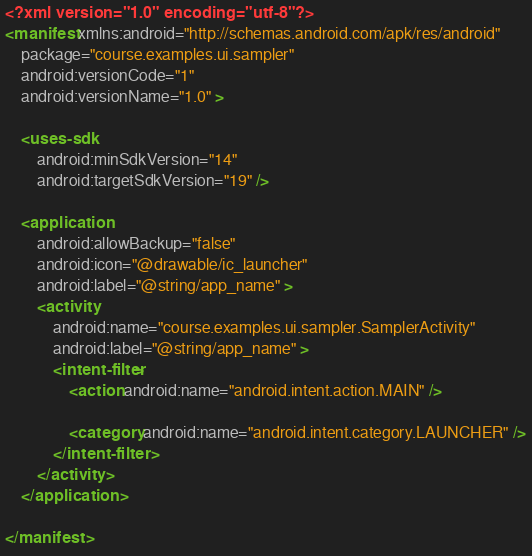Convert code to text. <code><loc_0><loc_0><loc_500><loc_500><_XML_><?xml version="1.0" encoding="utf-8"?>
<manifest xmlns:android="http://schemas.android.com/apk/res/android"
    package="course.examples.ui.sampler"
    android:versionCode="1"
    android:versionName="1.0" >

    <uses-sdk
        android:minSdkVersion="14"
        android:targetSdkVersion="19" />

    <application
        android:allowBackup="false"
        android:icon="@drawable/ic_launcher"
        android:label="@string/app_name" >
        <activity
            android:name="course.examples.ui.sampler.SamplerActivity"
            android:label="@string/app_name" >
            <intent-filter>
                <action android:name="android.intent.action.MAIN" />

                <category android:name="android.intent.category.LAUNCHER" />
            </intent-filter>
        </activity>
    </application>

</manifest></code> 